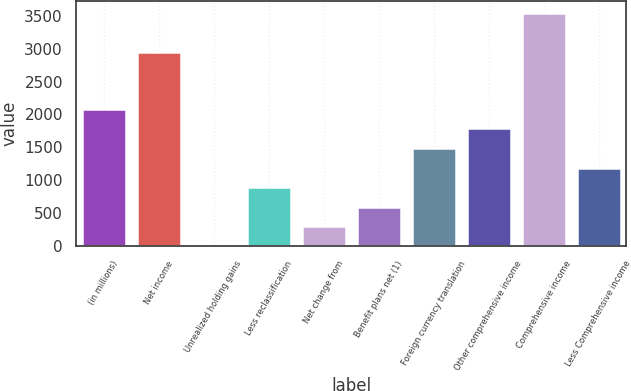<chart> <loc_0><loc_0><loc_500><loc_500><bar_chart><fcel>(in millions)<fcel>Net income<fcel>Unrealized holding gains<fcel>Less reclassification<fcel>Net change from<fcel>Benefit plans net (1)<fcel>Foreign currency translation<fcel>Other comprehensive income<fcel>Comprehensive income<fcel>Less Comprehensive income<nl><fcel>2083.7<fcel>2951<fcel>4<fcel>895.3<fcel>301.1<fcel>598.2<fcel>1489.5<fcel>1786.6<fcel>3545.2<fcel>1192.4<nl></chart> 